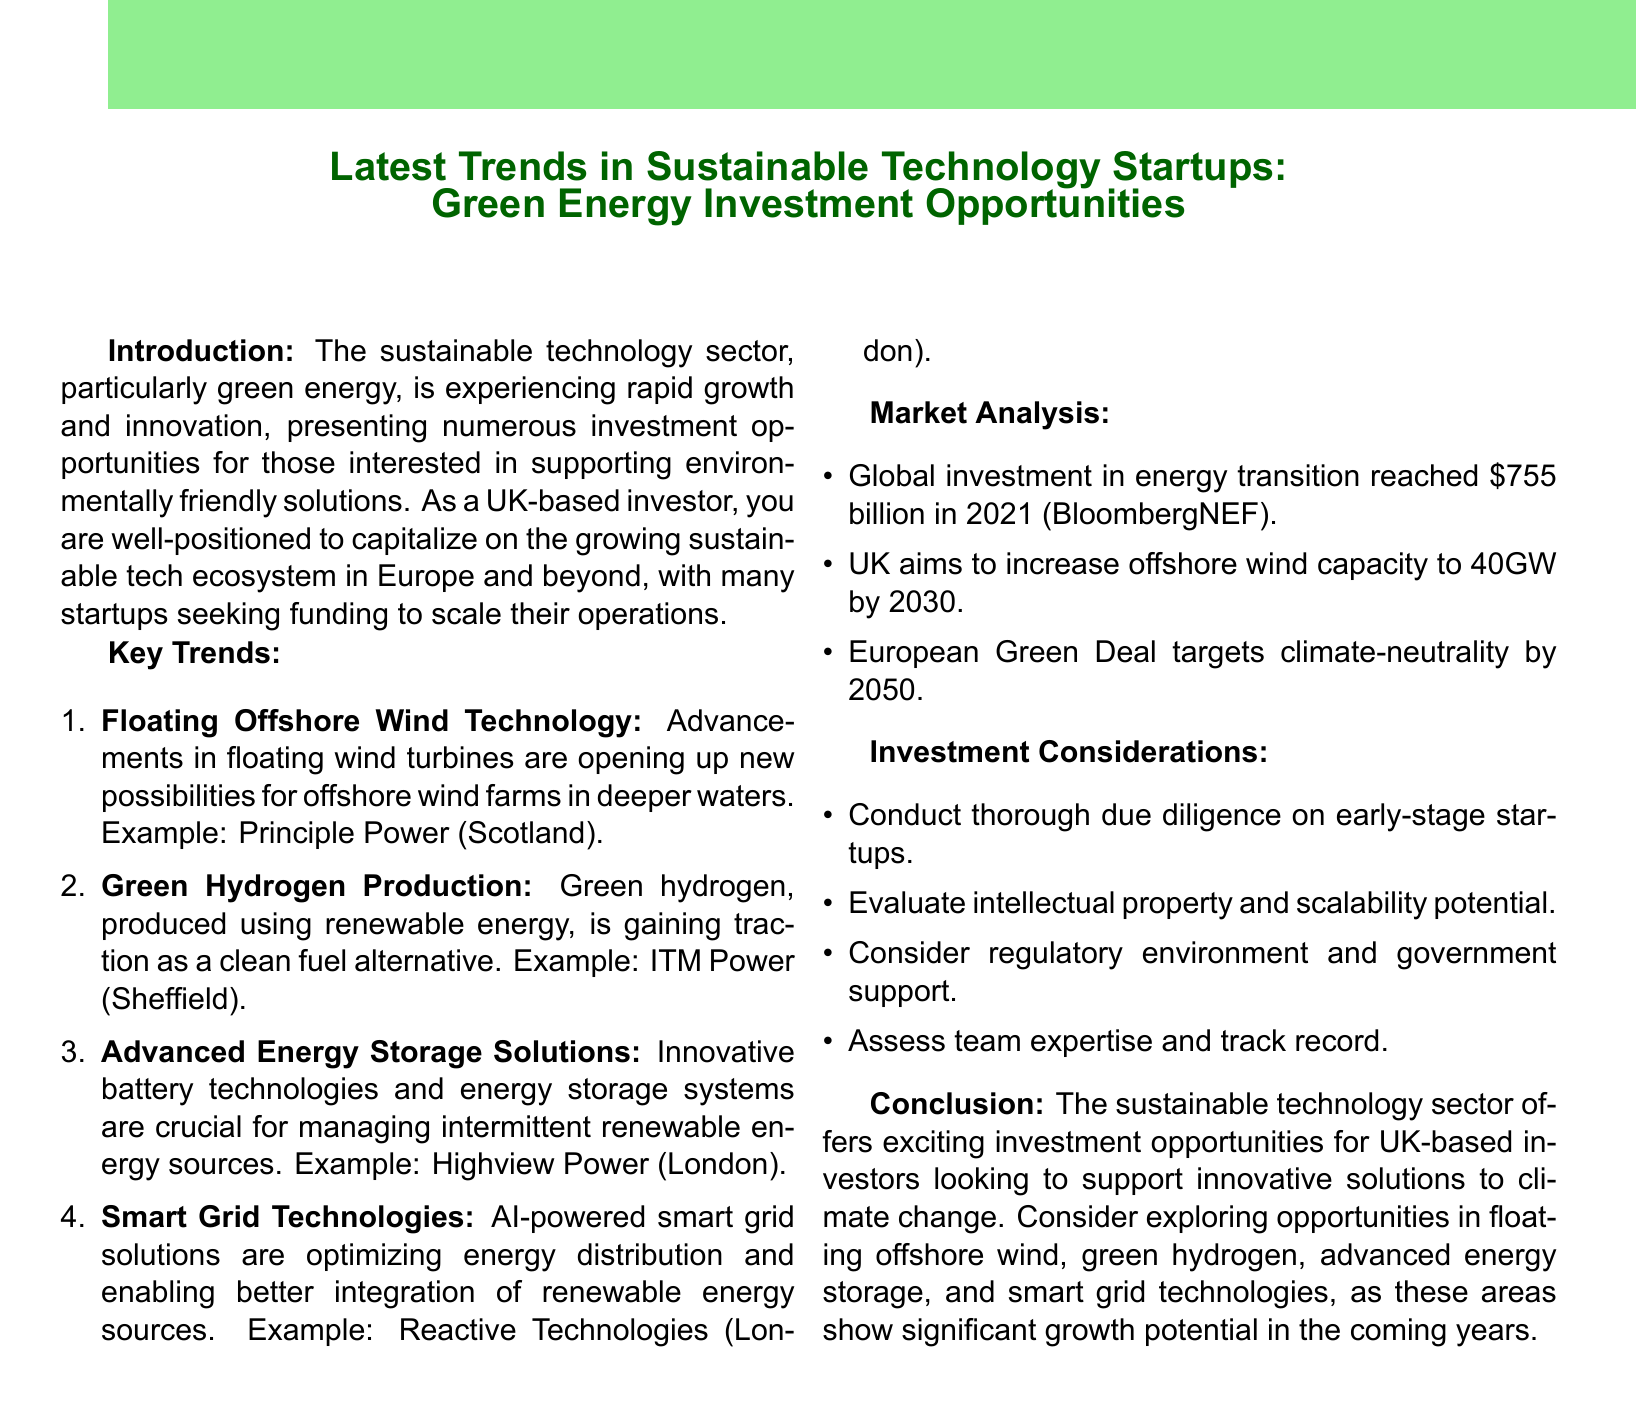What is the memo title? The title summarizes the content and focus of the memo, which is on sustainable technology startups in green energy.
Answer: Latest Trends in Sustainable Technology Startups: Green Energy Investment Opportunities Which company is based in Scotland? The document provides an example company that specializes in floating offshore wind technology, located in Scotland.
Answer: Principle Power What is the global investment amount mentioned for the energy transition in 2021? The document cites a specific figure indicating the total global investment in the energy transition for that year.
Answer: $755 billion What technology is Reactive Technologies developing? The memo identifies a specific type of technology related to smart grids provided by a London-based company.
Answer: Smart grid solutions What is the government’s target for offshore wind capacity in the UK by 2030? The document contains a clear target set by the UK government regarding renewable energy capacity.
Answer: 40GW Which type of fuel alternative is gaining traction according to the memo? The memo discusses a specific clean fuel alternative being produced with renewable energy.
Answer: Green hydrogen What was stated as a key consideration for investing in early-stage startups? The document lists crucial factors investors should consider when making investment decisions in this sector.
Answer: Due diligence What market does the European Green Deal aim to address by 2050? The memo highlights a long-term goal of the European Green Deal related to climate change and sustainability.
Answer: Climate-neutrality 